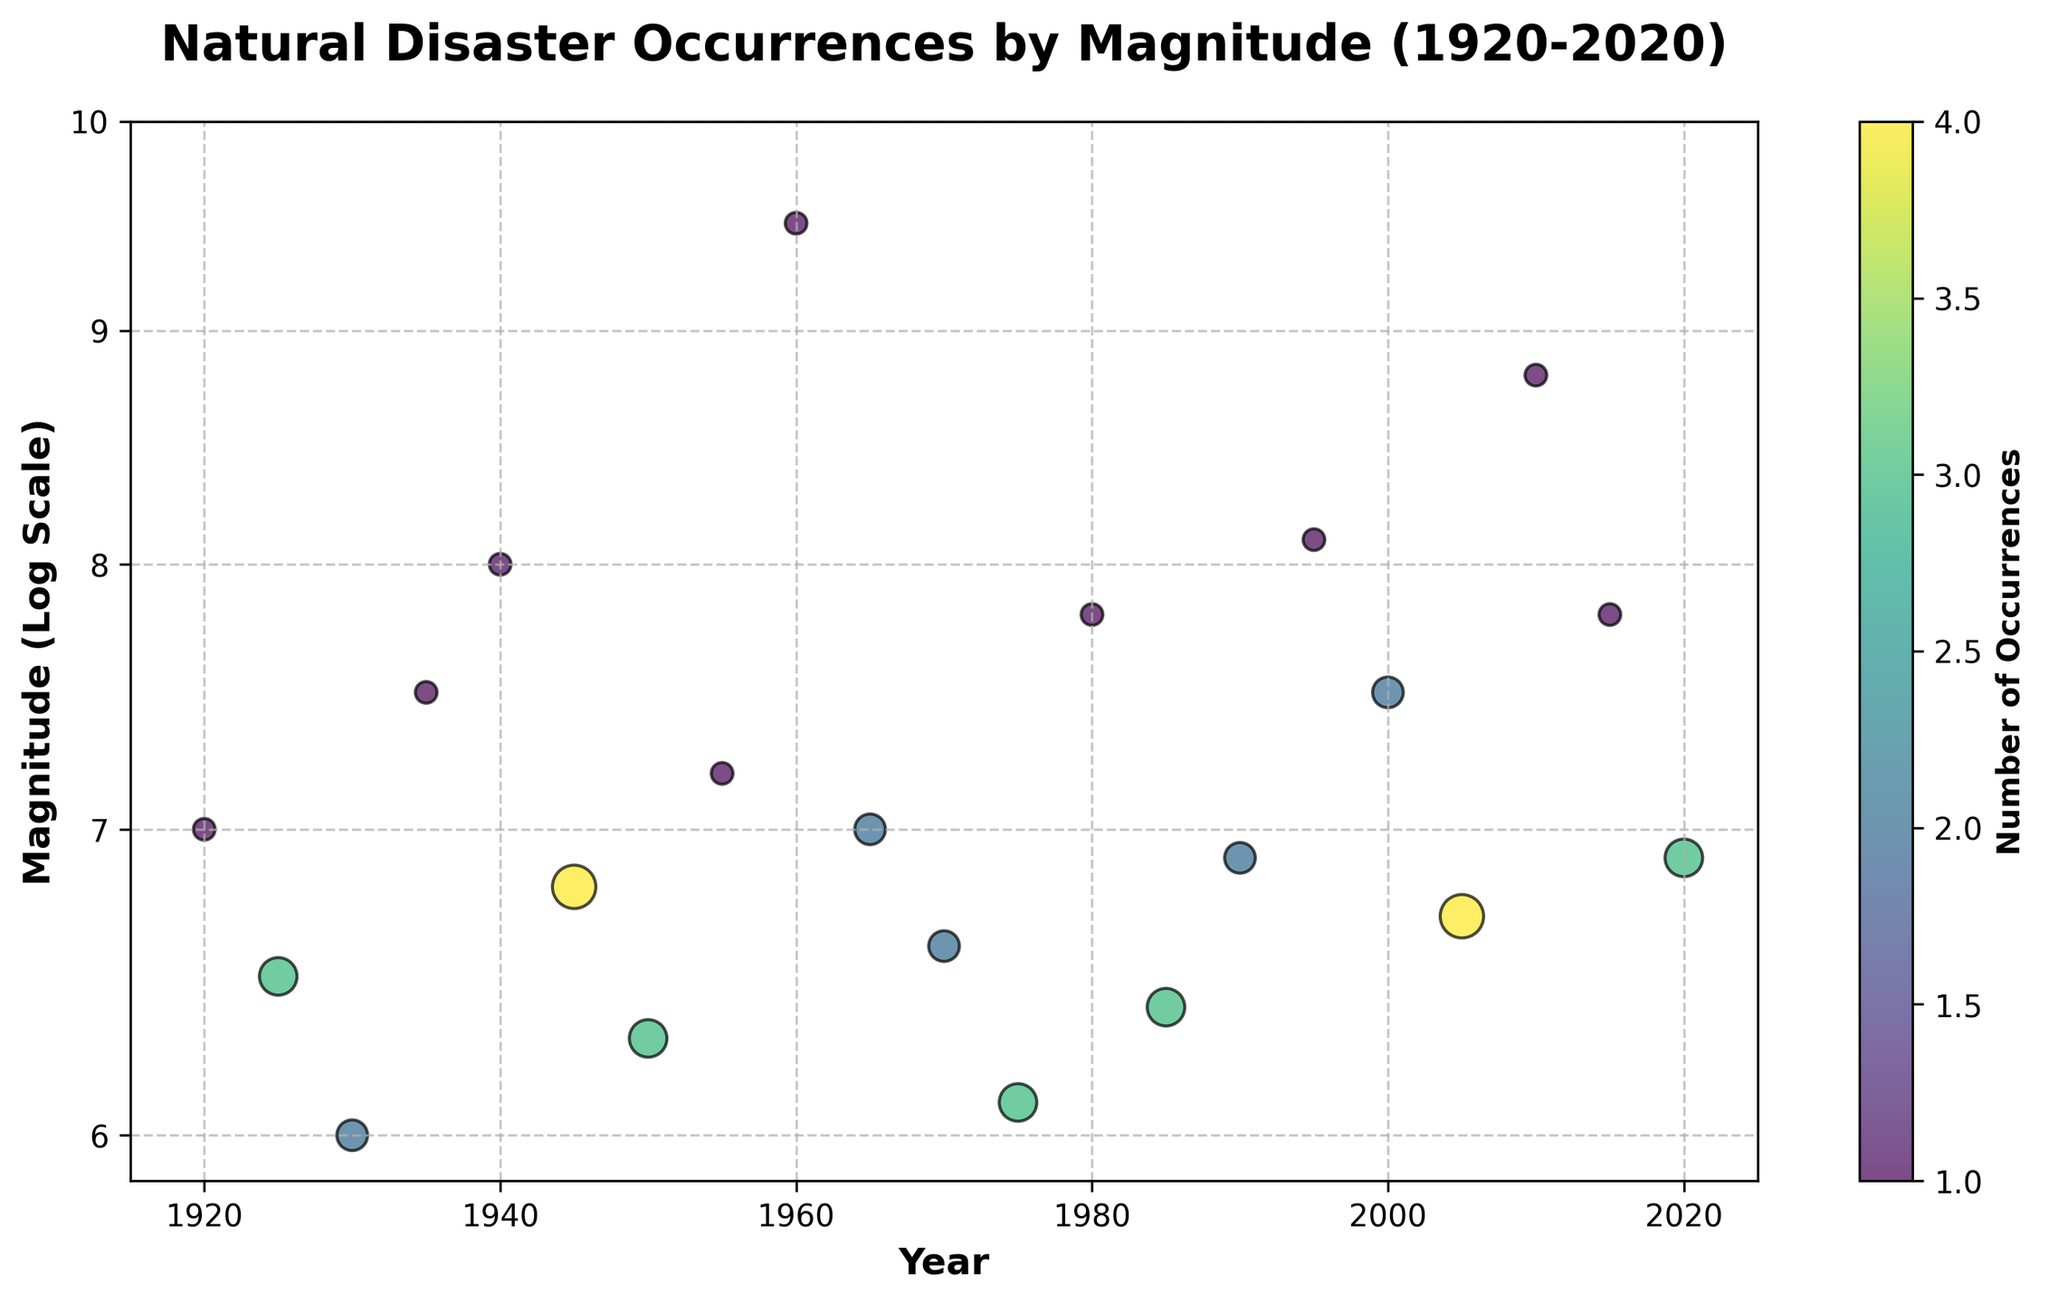what is the title of the plot? The title appears prominently at the top of the plot in bold font. It provides a summary of what the plot is about, focusing on the occurrence of natural disasters by magnitude over a century.
Answer: Natural Disaster Occurrences by Magnitude (1920-2020) Which year has the highest magnitude of natural disaster occurrences? By observing the y-axis labeled 'Magnitude (Log Scale)', the data point corresponding to 1960 reaches the highest magnitude.
Answer: 1960 How many occurrences of natural disasters are shown for the year 1945? The size of the scatter point and the color intensity indicates the number of occurrences. For 1945, the point is relatively large and dark, indicative of a higher occurrence. Checking the legend, it aligns with 4 occurrences.
Answer: 4 What is the general trend in the occurrences of natural disasters over the century? Observing the density and spread of scatter points over time, there is no consistent increasing or decreasing pattern; occurrences seem sporadic across the years.
Answer: Sporadic Which decade experienced the most occurrences of disasters with a magnitude of 7.0 or higher? Examine the scatter points that align with magnitudes 7.0 and above, then count the number of points per decade. The 2000s (including 2000, 2005, 2010) have a higher combined count of events.
Answer: 2000s How does the number of occurrences compare between 2000 and 2005? Check the sizes and color intensity of the points for the years 2000 and 2005. Both have equal sizes, indicating the same number of occurrences.
Answer: Equal Is there any year where multiple points are shown with varying magnitudes? Reviewing the plot, each year hosts a single scatter point representing occurrences, meaning no year accommodates different magnitudes.
Answer: No What is the range of magnitudes represented in the plot? Examine the vertical spread of points along the y-axis. The data range from a magnitude of 6.0 to 9.5.
Answer: 6.0 to 9.5 When did the next highest magnitude after 1960 occur, and how does it compare in occurrences? Identify the next highest magnitude point, which is in 2010 with a magnitude of 8.8, occurring once compared to the single 1960 occurrence.
Answer: 2010, one occurrence Which year has a higher magnitude disaster: 1995 or 1980? Comparing the y-axis positions of the points for both years, 1995 has a slightly higher magnitude of 8.1 versus 7.8 in 1980.
Answer: 1995 